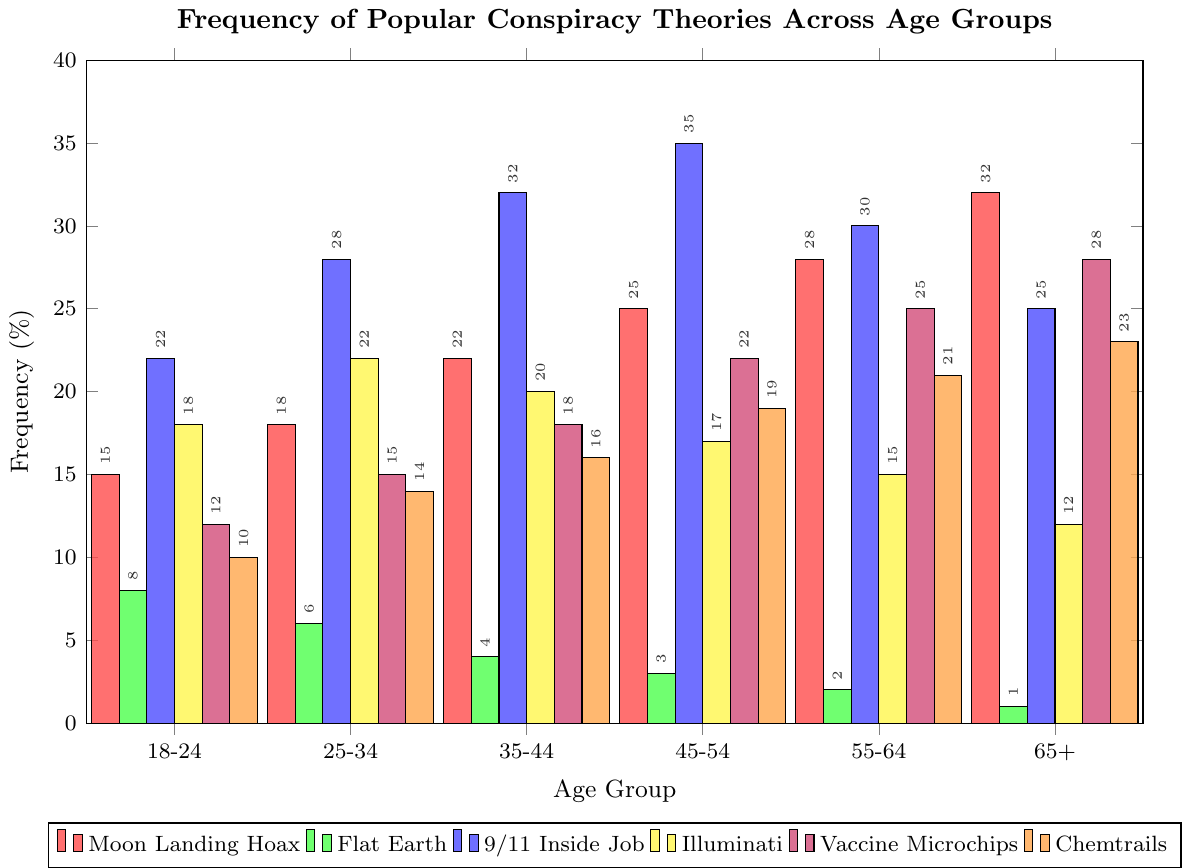What's the most popular conspiracy theory in the 18-24 age group? The highest bar in the 18-24 age group corresponds to the 9/11 Inside Job conspiracy theory, with a frequency of 22%.
Answer: 9/11 Inside Job Which age group has the highest belief in the Moon Landing Hoax? The highest bar for the Moon Landing Hoax is in the 65+ age group, with a frequency of 32%.
Answer: 65+ Is the frequency of belief in Flat Earth higher among younger or older age groups? The bars for Flat Earth decrease as the age groups increase, indicating a higher frequency among younger age groups.
Answer: Younger age groups Compare the belief in Vaccine Microchips between the 35-44 and 65+ age groups. The 35-44 age group has a 18% frequency, while the 65+ age group has a 28% frequency, showing that belief in Vaccine Microchips is higher in the 65+ age group.
Answer: 65+ age group What is the sum of frequencies for the Illuminati theory across all age groups? The frequencies for Illuminati are 18, 22, 20, 17, 15, and 12. Summing these up: 18 + 22 + 20 + 17 + 15 + 12 = 104
Answer: 104 Which conspiracy theory has the smallest difference in frequency between the 25-34 and 45-54 age groups? Calculate the absolute differences: Moon Landing Hoax (25-18=7), Flat Earth (3-6=3), 9/11 Inside Job (35-28=7), Illuminati (17-22=5), Vaccine Microchips (22-15=7), Chemtrails (19-14=5). The smallest difference is 3 for Flat Earth.
Answer: Flat Earth What is the visual difference between the Chemtrails bar in the 18-24 age group and the 25-34 age group? Visually, the Chemtrails bar in the 25-34 age group is visibly higher than in the 18-24 age group, with respective frequencies of 14% and 10%.
Answer: Higher in 25-34 age group How does the frequency of belief in the Moon Landing Hoax change with age? The frequency of belief in the Moon Landing Hoax increases as the age groups progress from 18-24 to 65+, starting at 15% and peaking at 32%.
Answer: Increases with age Which age group has the lowest frequency for the Chemtrails conspiracy theory? The lowest bar for Chemtrails is in the 18-24 age group, with a frequency of 10%.
Answer: 18-24 age group What's the average frequency of belief in the 9/11 Inside Job conspiracy across all age groups? Calculate the average: (22 + 28 + 32 + 35 + 30 + 25) / 6 = 28.67.
Answer: 28.67 